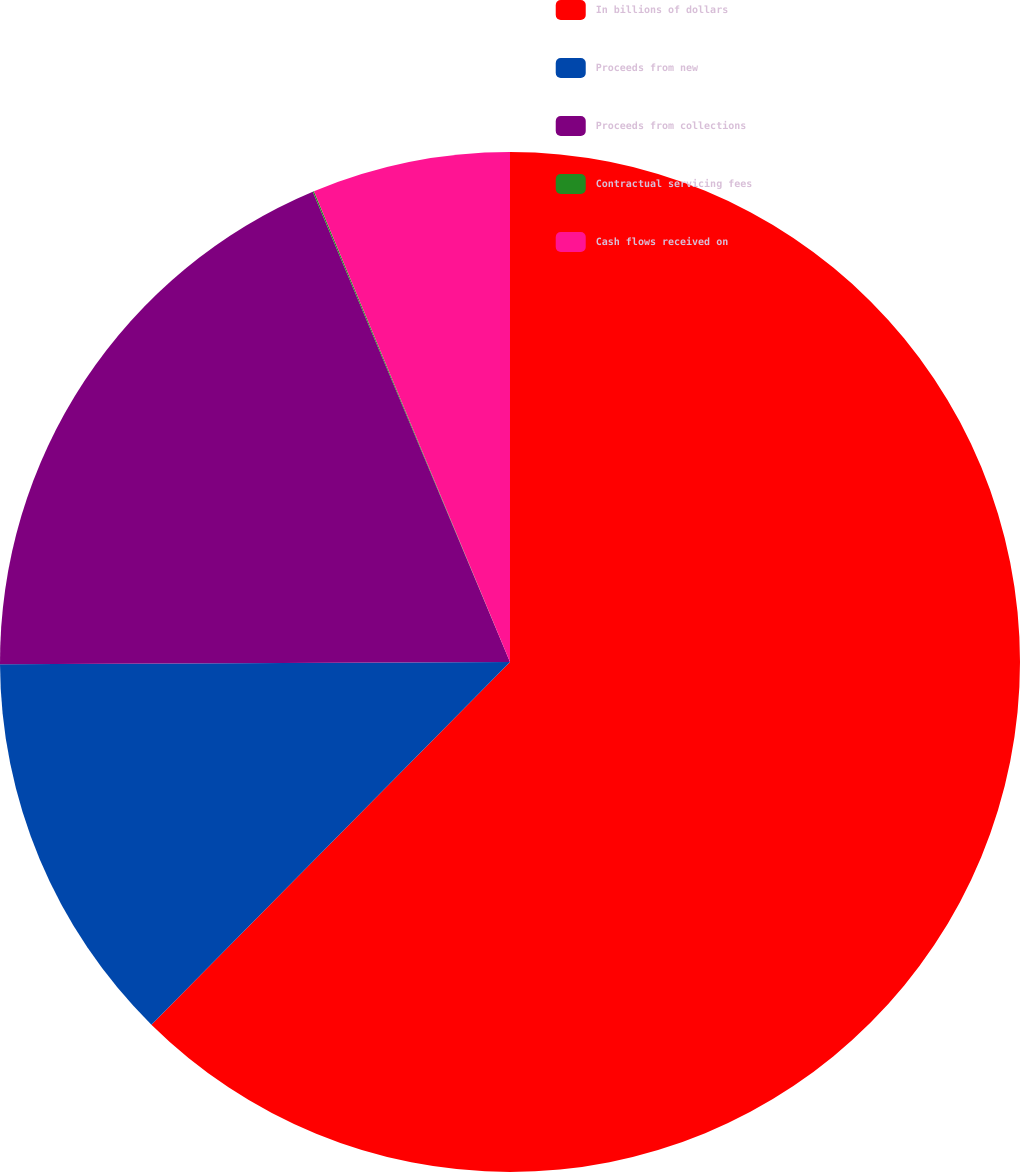<chart> <loc_0><loc_0><loc_500><loc_500><pie_chart><fcel>In billions of dollars<fcel>Proceeds from new<fcel>Proceeds from collections<fcel>Contractual servicing fees<fcel>Cash flows received on<nl><fcel>62.41%<fcel>12.52%<fcel>18.75%<fcel>0.04%<fcel>6.28%<nl></chart> 